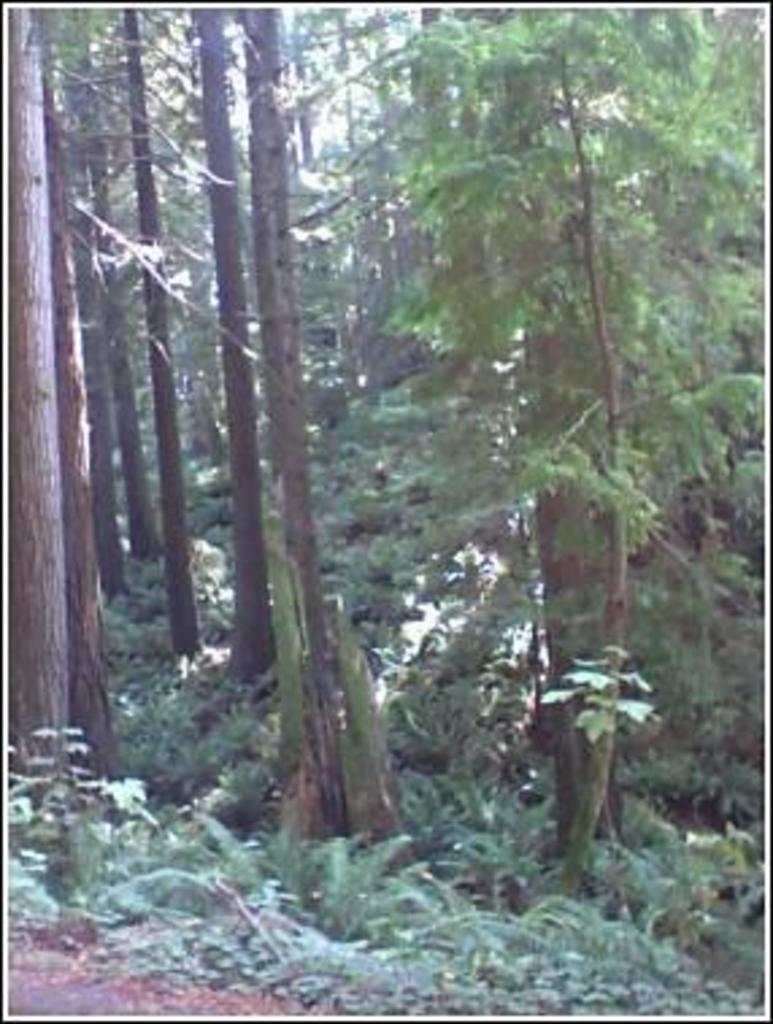What type of environment is shown in the image? The image depicts a forest. What are the characteristics of the trees in the forest? The trees in the forest are tall. What can be seen at the bottom of the image? There are small plants and sand visible at the bottom of the image. What type of discussion is taking place among the lizards in the forest? There are no lizards present in the image, so it is not possible to determine if a discussion is taking place. What type of steel is used to construct the trees in the forest? The trees in the forest are natural, and there is no steel used in their construction. 